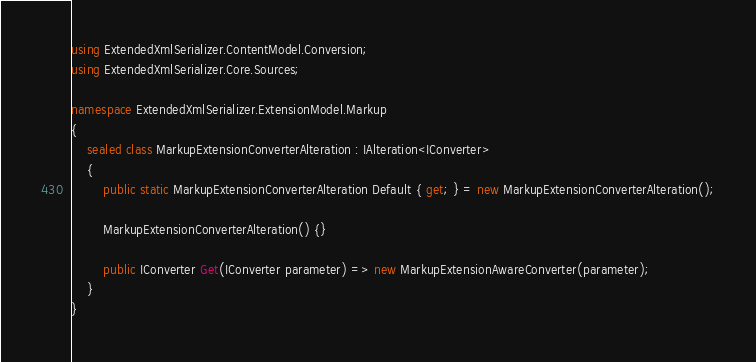Convert code to text. <code><loc_0><loc_0><loc_500><loc_500><_C#_>using ExtendedXmlSerializer.ContentModel.Conversion;
using ExtendedXmlSerializer.Core.Sources;

namespace ExtendedXmlSerializer.ExtensionModel.Markup
{
	sealed class MarkupExtensionConverterAlteration : IAlteration<IConverter>
	{
		public static MarkupExtensionConverterAlteration Default { get; } = new MarkupExtensionConverterAlteration();

		MarkupExtensionConverterAlteration() {}

		public IConverter Get(IConverter parameter) => new MarkupExtensionAwareConverter(parameter);
	}
}</code> 